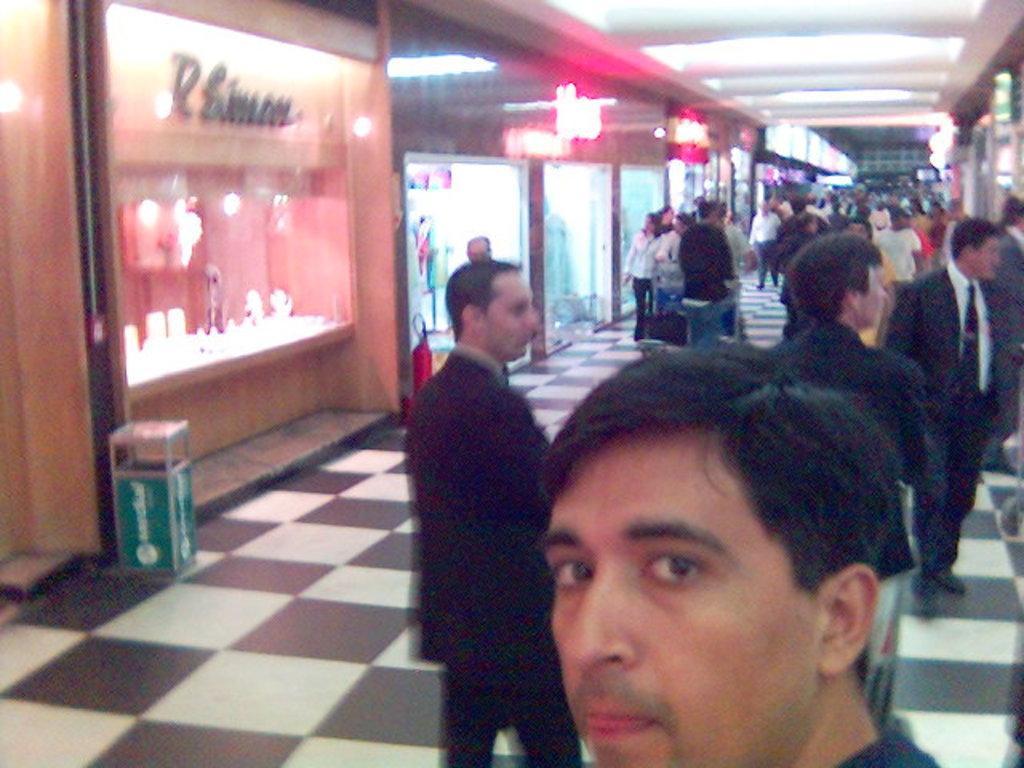Please provide a concise description of this image. In this image we can see a group of people standing on the ground, some persons are holding a cart with some bags. In the background, we can see fire extinguisher and a box placed on the ground, a group of buildings, some objects, sign boards with text and some lights. 